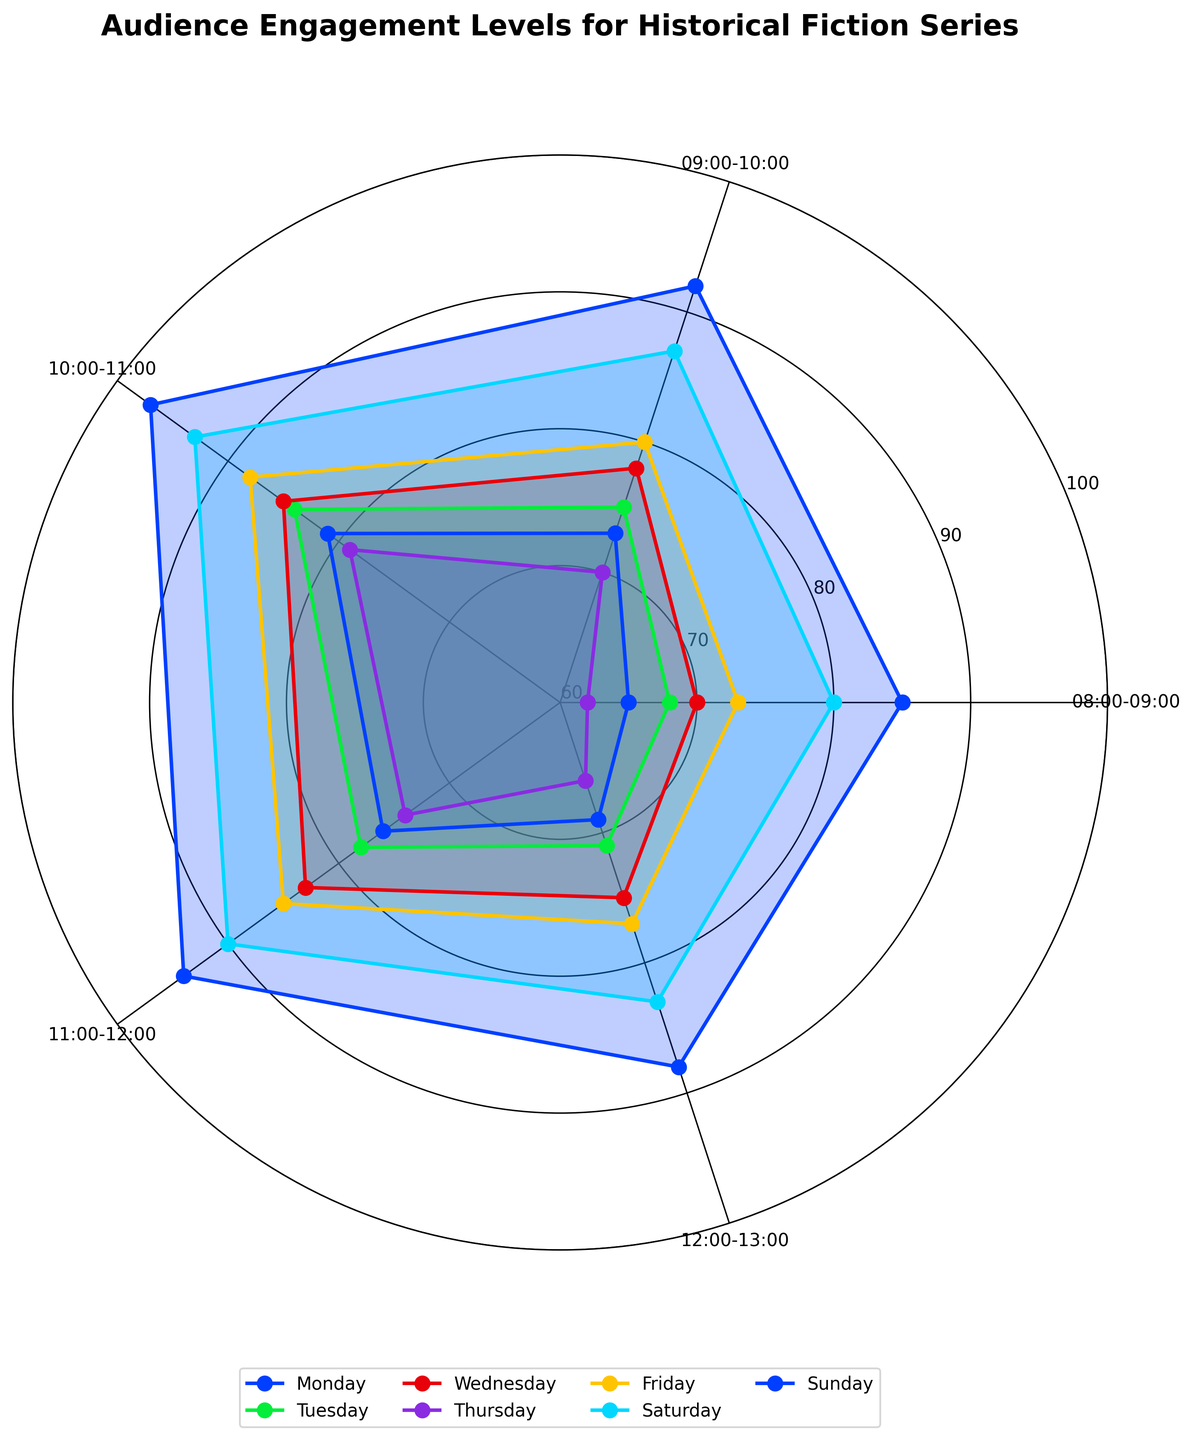What is the title of the chart? The title of the chart is typically at the top, above the plot area. Here, it reads "Audience Engagement Levels for Historical Fiction Series".
Answer: Audience Engagement Levels for Historical Fiction Series How many time slots are shown in the plot? The number of time slots can be identified by counting the segments on the chart, excluding the repeated segment. Each unique time slot appears once.
Answer: 5 On which day is the highest engagement level at the 10:00-11:00 time slot? The values for 10:00-11:00 on each day need to be compared. Friday has the highest engagement level of 88 for this time slot.
Answer: Sunday What is the engagement level range covered in the chart? Looking at the radial axis, the range is determined by the lowest and highest engagement level tick marks, which are from 60 to 100.
Answer: 60 to 100 Which day shows the lowest engagement level at the 08:00-09:00 time slot? By comparing engagement levels for 08:00-09:00 across all days, Thursday shows the lowest level at 62.
Answer: Thursday What is the average engagement level for Sunday across all time slots? Sum the engagement levels for Sunday (85 + 92 + 97 + 94 + 88) and divide by the number of time slots, which is 5. The calculation is (85 + 92 + 97 + 94 + 88) / 5 = 91.2
Answer: 91.2 How does the engagement level on Wednesday at 11:00-12:00 compare to Thursday at the same time slot? The chart shows Wednesday at 11:00-12:00 has 83, while Thursday at the same slot has 74. Thus, Wednesday's level is higher.
Answer: Wednesday's level is higher What is the overall trend in engagement levels from 08:00-09:00 to 12:00-13:00 for Monday? By visually inspecting the plot segment for Monday, the engagement levels are 65, 73, 81, 76, 69, showing a rise from 65 to 81, then a downward trend to 69.
Answer: Rise, then fall Which day has the highest average engagement level? Calculate the average for all days and compare: Sunday (91.2), Saturday (86.6), Friday (80.6), Thursday (70.2), Wednesday (78.2), Tuesday (75.2), Monday (72.8). Sunday has the highest average.
Answer: Sunday How does Friday at 12:00-13:00 compare to the same time on Saturday? By comparing both days at 12:00-13:00, Friday has 77 while Saturday has 83. Saturday's level is higher.
Answer: Saturday's level is higher 